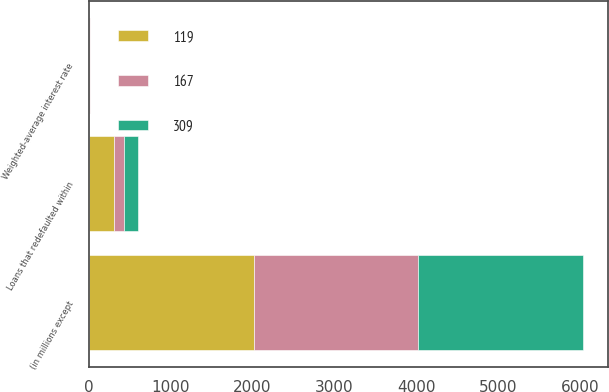Convert chart to OTSL. <chart><loc_0><loc_0><loc_500><loc_500><stacked_bar_chart><ecel><fcel>(in millions except<fcel>Weighted-average interest rate<fcel>Loans that redefaulted within<nl><fcel>167<fcel>2014<fcel>4.4<fcel>119<nl><fcel>309<fcel>2013<fcel>4.38<fcel>167<nl><fcel>119<fcel>2012<fcel>5.19<fcel>309<nl></chart> 